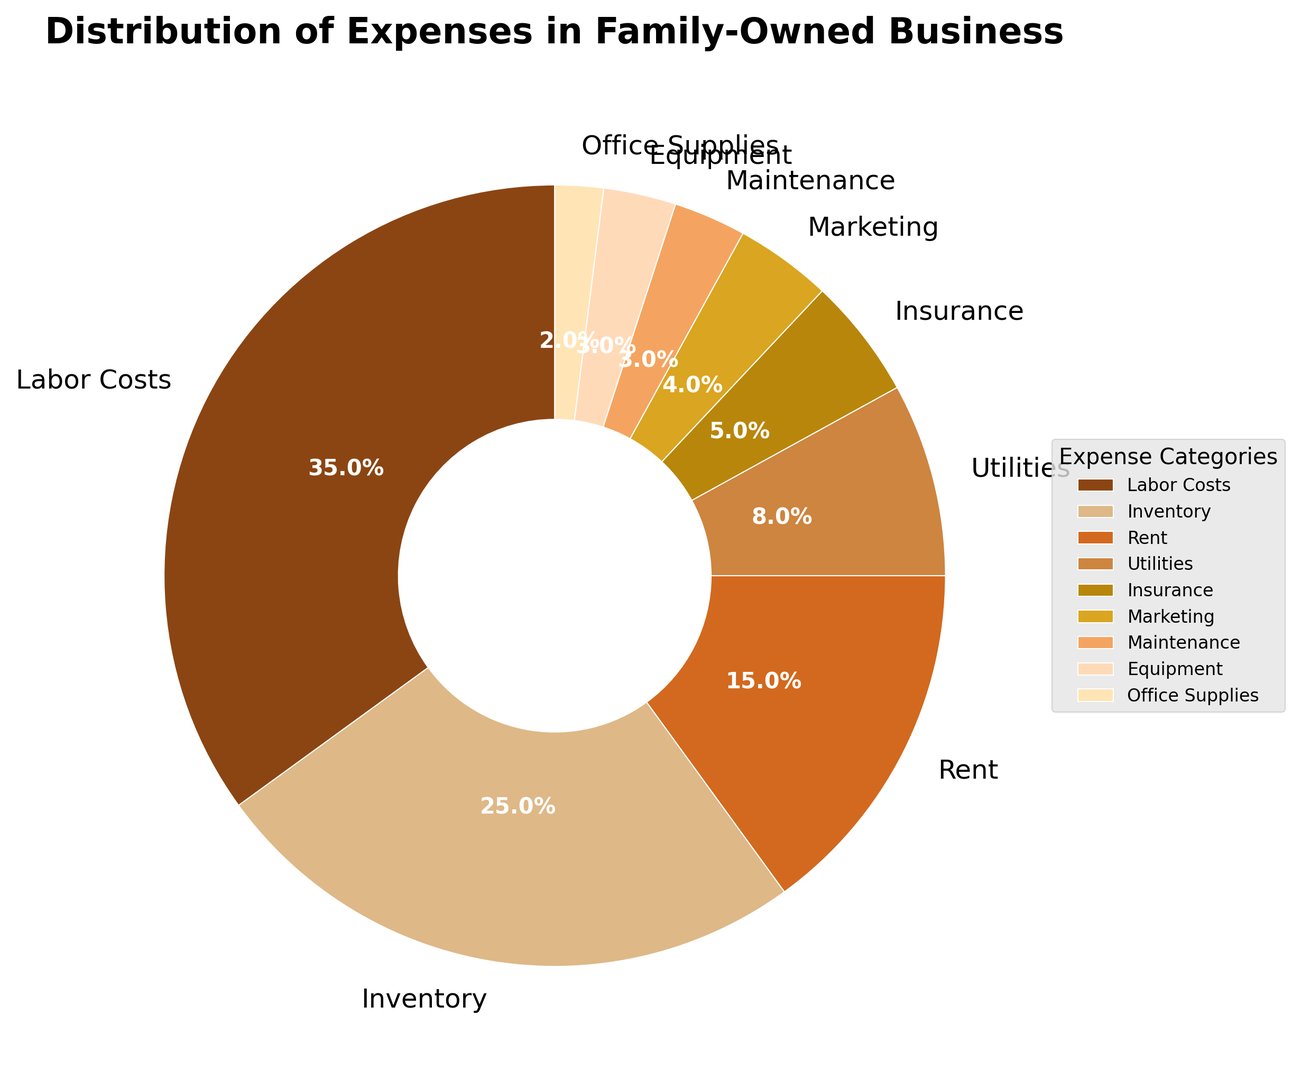Which expense category has the highest percentage in the pie chart? The largest slice in the pie chart is labeled "Labor Costs," which makes up 35% of the total expenses.
Answer: Labor Costs What is the combined percentage of Inventory and Rent? The pie chart shows Inventory at 25% and Rent at 15%. Adding these together gives 25% + 15% = 40%.
Answer: 40% Compare the percentages of Utilities and Insurance. Which one is higher and by how much? Utilities are at 8% while Insurance is at 5%. The difference between them is 8% - 5% = 3%. Thus, Utilities are 3% higher.
Answer: Utilities are higher by 3% How much more is spent on Marketing compared to Equipment? The pie chart shows Marketing at 4% and Equipment at 3%. The difference is 4% - 3% = 1%. Therefore, 1% more is spent on Marketing compared to Equipment.
Answer: 1% What are the total percentages of all expenses categorized below 5%? Adding the percentages for Insurance (5%), Marketing (4%), Maintenance (3%), Equipment (3%), and Office Supplies (2%): 5% + 4% + 3% + 3% + 2% = 17%
Answer: 17% Which expense categories are visually represented by lighter brown colors? The lighter brown colors visually represent Insurance (5%), Marketing (4%), Maintenance (3%), Equipment (3%), and Office Supplies (2%). These categories are visually less prominent due to their lighter color and smaller size in the chart.
Answer: Insurance, Marketing, Maintenance, Equipment, Office Supplies If the total expenses were $100,000, how much would be spent on Rent? Rent makes up 15% of the total expenses. To find out the amount spent, calculate 15% of $100,000, which is 0.15 * 100,000 = $15,000.
Answer: $15,000 What is the visual relationship between the categories Maintenance and Office Supplies in terms of their percentages? Both Maintenance and Office Supplies show relatively small areas on the pie chart. Maintenance is at 3% and Office Supplies at 2%, so Maintenance is slightly larger than Office Supplies by 1%.
Answer: Maintenance is larger by 1% Which three expense categories together make up more than 50% of the total expenses? Labor Costs (35%), Inventory (25%), and Rent (15%) are the three largest categories. Adding them: 35% + 25% + 15% = 75%, showing they together exceed 50%.
Answer: Labor Costs, Inventory, Rent 